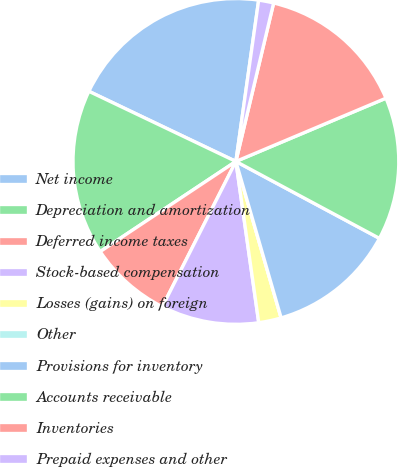Convert chart to OTSL. <chart><loc_0><loc_0><loc_500><loc_500><pie_chart><fcel>Net income<fcel>Depreciation and amortization<fcel>Deferred income taxes<fcel>Stock-based compensation<fcel>Losses (gains) on foreign<fcel>Other<fcel>Provisions for inventory<fcel>Accounts receivable<fcel>Inventories<fcel>Prepaid expenses and other<nl><fcel>20.15%<fcel>16.42%<fcel>8.21%<fcel>9.7%<fcel>2.24%<fcel>0.0%<fcel>12.69%<fcel>14.18%<fcel>14.93%<fcel>1.49%<nl></chart> 